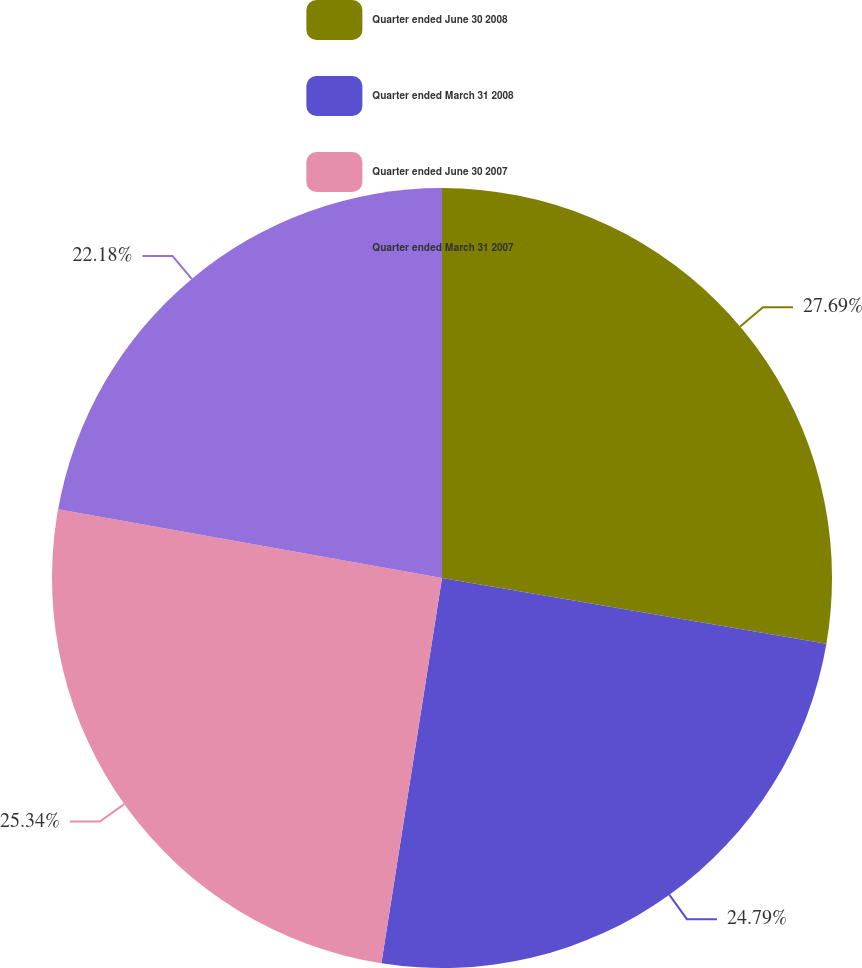Convert chart to OTSL. <chart><loc_0><loc_0><loc_500><loc_500><pie_chart><fcel>Quarter ended June 30 2008<fcel>Quarter ended March 31 2008<fcel>Quarter ended June 30 2007<fcel>Quarter ended March 31 2007<nl><fcel>27.7%<fcel>24.79%<fcel>25.34%<fcel>22.18%<nl></chart> 